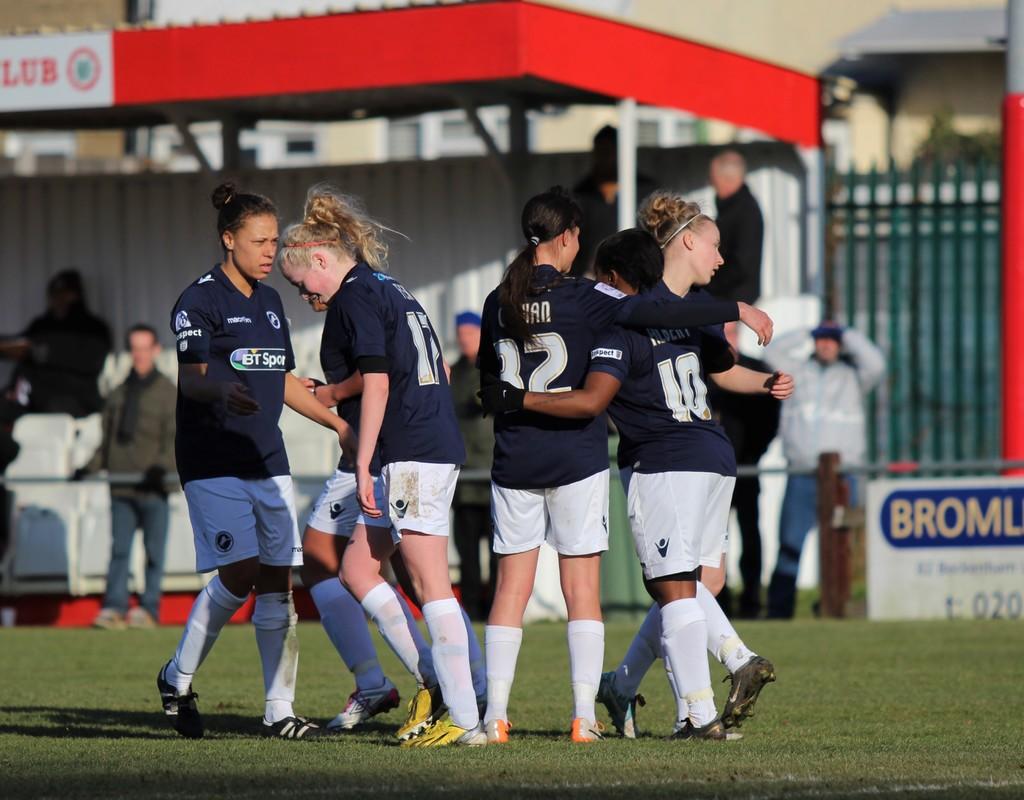What is the middle girls number?
Give a very brief answer. 12. 